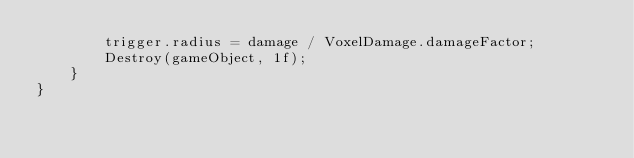<code> <loc_0><loc_0><loc_500><loc_500><_C#_>        trigger.radius = damage / VoxelDamage.damageFactor;
        Destroy(gameObject, 1f);
    }
}
</code> 